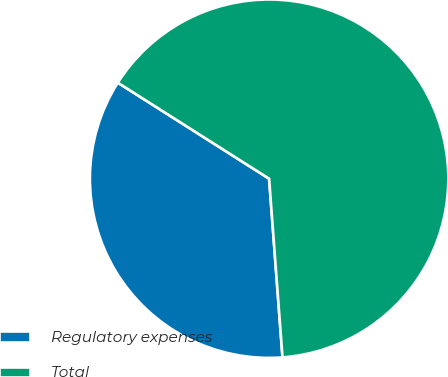<chart> <loc_0><loc_0><loc_500><loc_500><pie_chart><fcel>Regulatory expenses<fcel>Total<nl><fcel>35.19%<fcel>64.81%<nl></chart> 